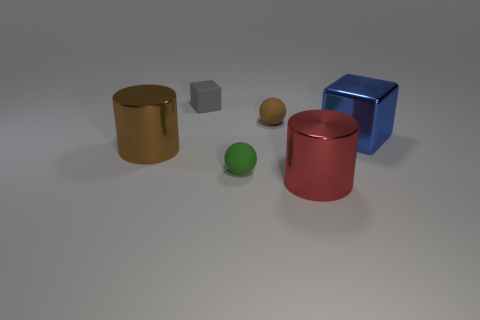Add 2 small spheres. How many objects exist? 8 Subtract all blue blocks. How many blocks are left? 1 Subtract all yellow cubes. Subtract all green balls. How many cubes are left? 2 Subtract all blue shiny objects. Subtract all gray objects. How many objects are left? 4 Add 5 small green things. How many small green things are left? 6 Add 1 big red metal objects. How many big red metal objects exist? 2 Subtract 1 green balls. How many objects are left? 5 Subtract all cubes. How many objects are left? 4 